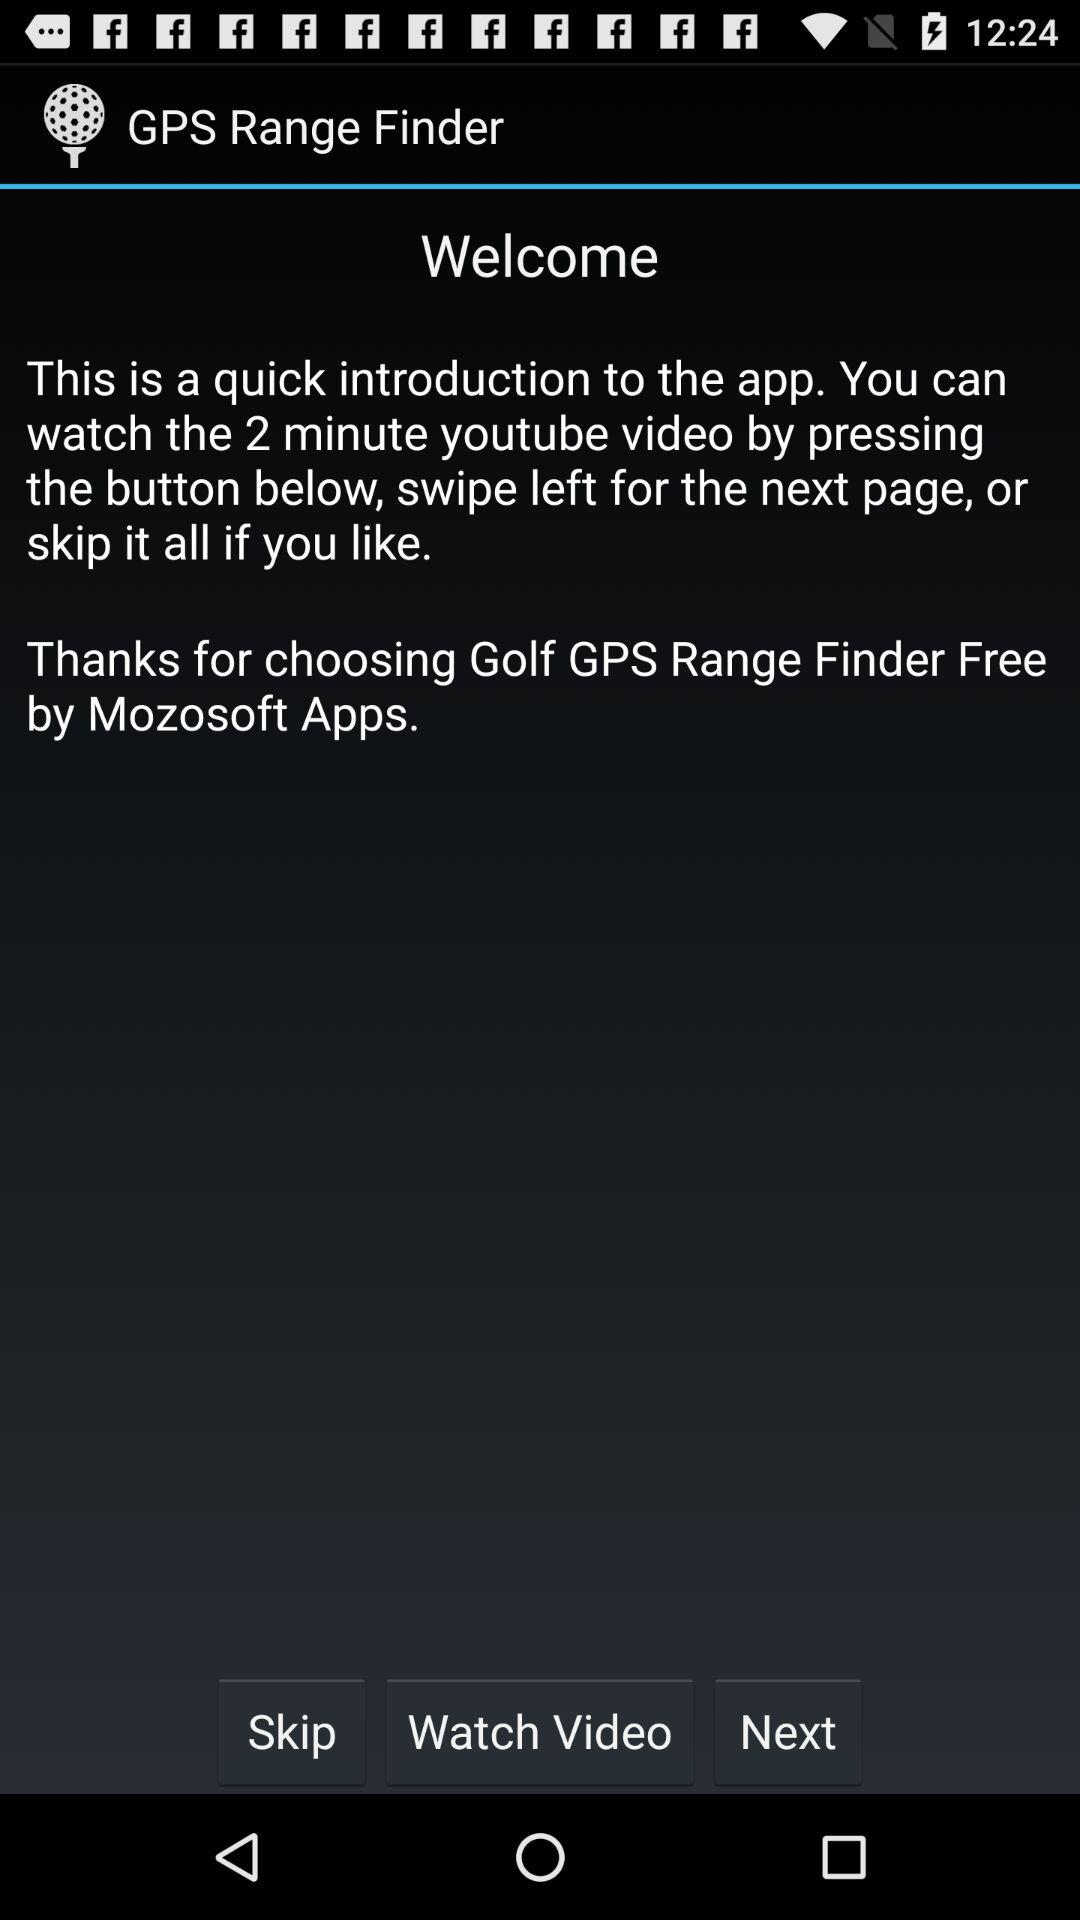What is the application name? The application name is "GPS Range Finder". 